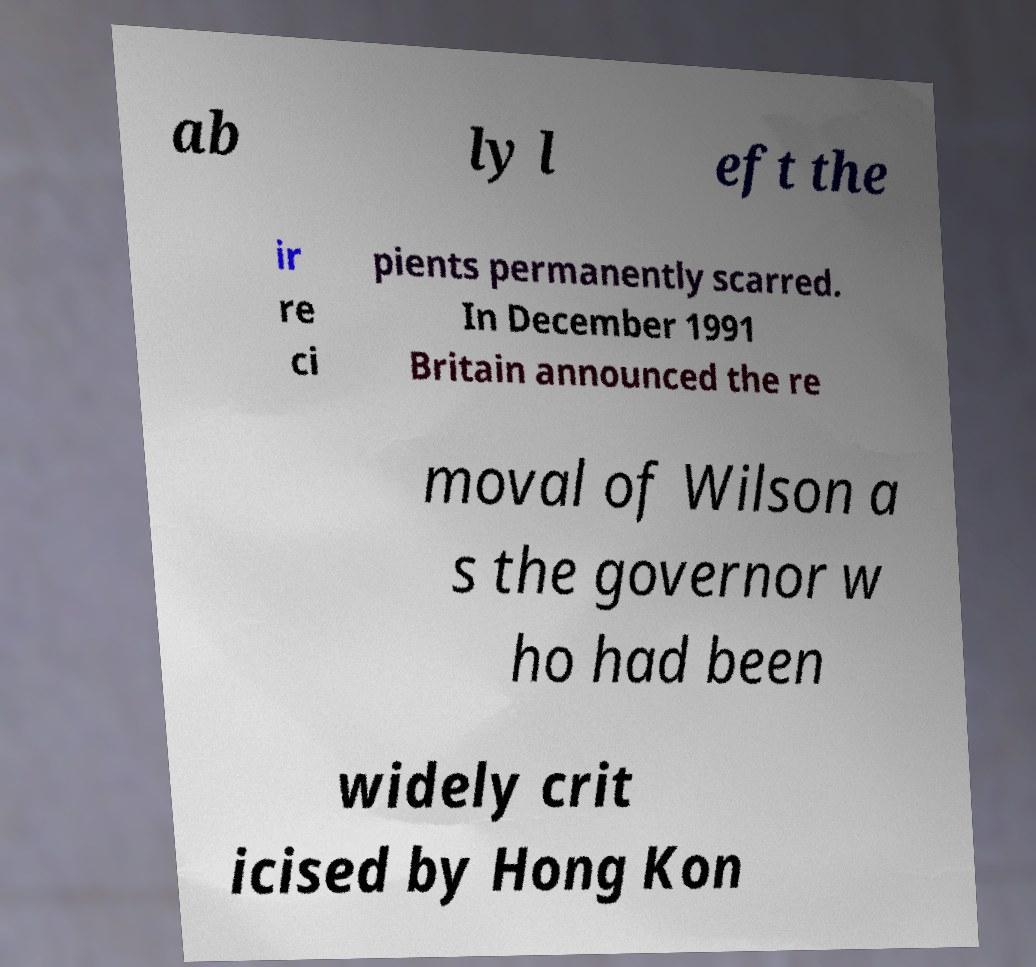What messages or text are displayed in this image? I need them in a readable, typed format. ab ly l eft the ir re ci pients permanently scarred. In December 1991 Britain announced the re moval of Wilson a s the governor w ho had been widely crit icised by Hong Kon 